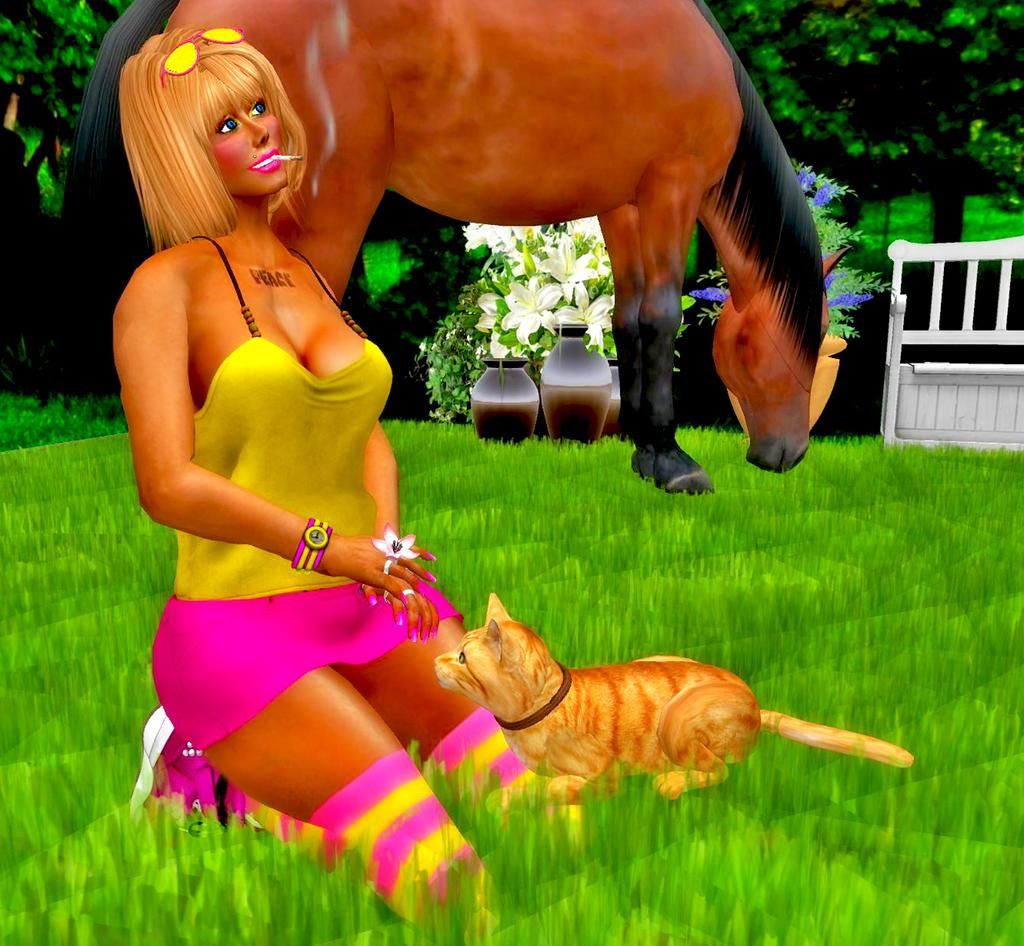What type of picture is the image? The image is an animated picture. Who or what can be seen in the image? There is a woman, a cat, and a horse in the image. What type of vegetation is present in the image? There are plants and trees in the image, as well as flowers. What type of furniture is in the image? There is a bench in the image. Where is the mailbox located in the image? There is no mailbox present in the image. What role does the actor play in the image? There is no actor present in the image, as it is an animated picture featuring a woman, a cat, and a horse. 